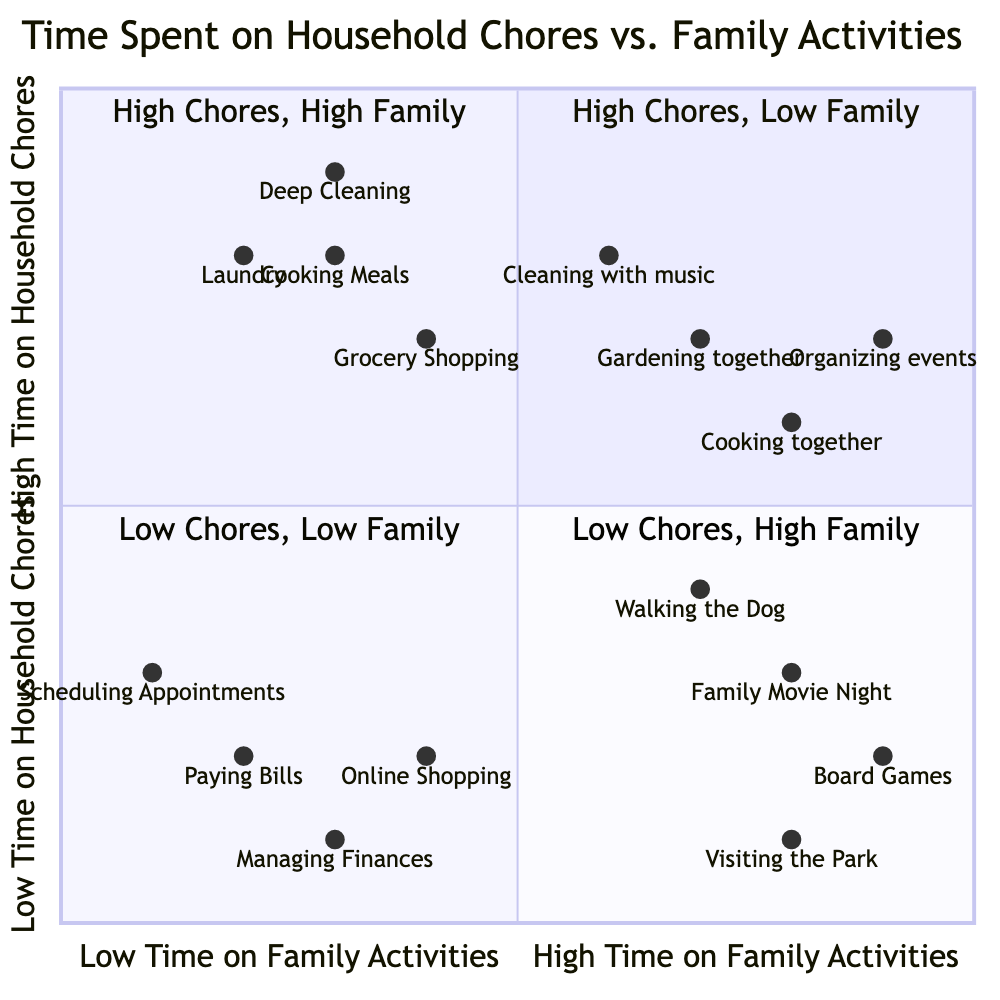What are the activities in the "High Time on Household Chores, Low Time on Family Activities" quadrant? This quadrant includes activities that consume a lot of time doing chores but not much time on family activities. The listed activities are Laundry, Deep Cleaning (e.g., bathrooms, floors), Grocery Shopping, and Cooking Meals.
Answer: Laundry, Deep Cleaning, Grocery Shopping, Cooking Meals Which activity has the highest time spent on family activities? To find this, I look at all the activities in each quadrant with high time spent on family activities. "Family Movie Night" and "Board Games" are in the “Low Time on Chores, High Time on Family Activities” quadrant, with "Family Movie Night" having the highest rate based on the data present.
Answer: Family Movie Night How many activities are in the "Low Time on Household Chores, Low Time on Family Activities" quadrant? The quadrant consists of activities that require little time on both chores and family activities. The activities listed are Paying Bills, Managing Finances, Scheduling Appointments, and Online Shopping for Necessities, totaling four.
Answer: 4 Which quadrant has activities that involve both high time on household chores and family activities? The question points to the quadrant where both aspects of time usage are high. This is designated as "High Time on Household Chores, High Time on Family Activities". The activities in this quadrant include Gardening together as a family, Cleaning while listening to music with kids, Cooking special meals together, and Organizing family events and parties.
Answer: High Time on Household Chores, High Time on Family Activities Which activity combines household chores and family involvement? To answer this, I analyze activities that feature both chores and family activities. "Gardening together as a family," "Cleaning while listening to music with kids," "Cooking special meals together," and "Organizing family events and parties" are identified as combining these aspects.
Answer: Gardening together as a family What is the relationship between "Cooking Meals" and family activities? "Cooking Meals" is characterized as an activity with high time on household chores (in the first quadrant) but low time on family activities based on its placement. It implies that while it takes considerable time for cooking, it does not involve significant family activities.
Answer: High time on chores, low time on family activities Which quadrant has the least engagement in household chores? The quadrant that denotes low involvement in household chores is "Low Time on Household Chores, Low Time on Family Activities", where activities like Paying Bills and Scheduling Appointments are listed. It indicates minimal time spent on both chores and activities.
Answer: Low Time on Household Chores, Low Time on Family Activities 